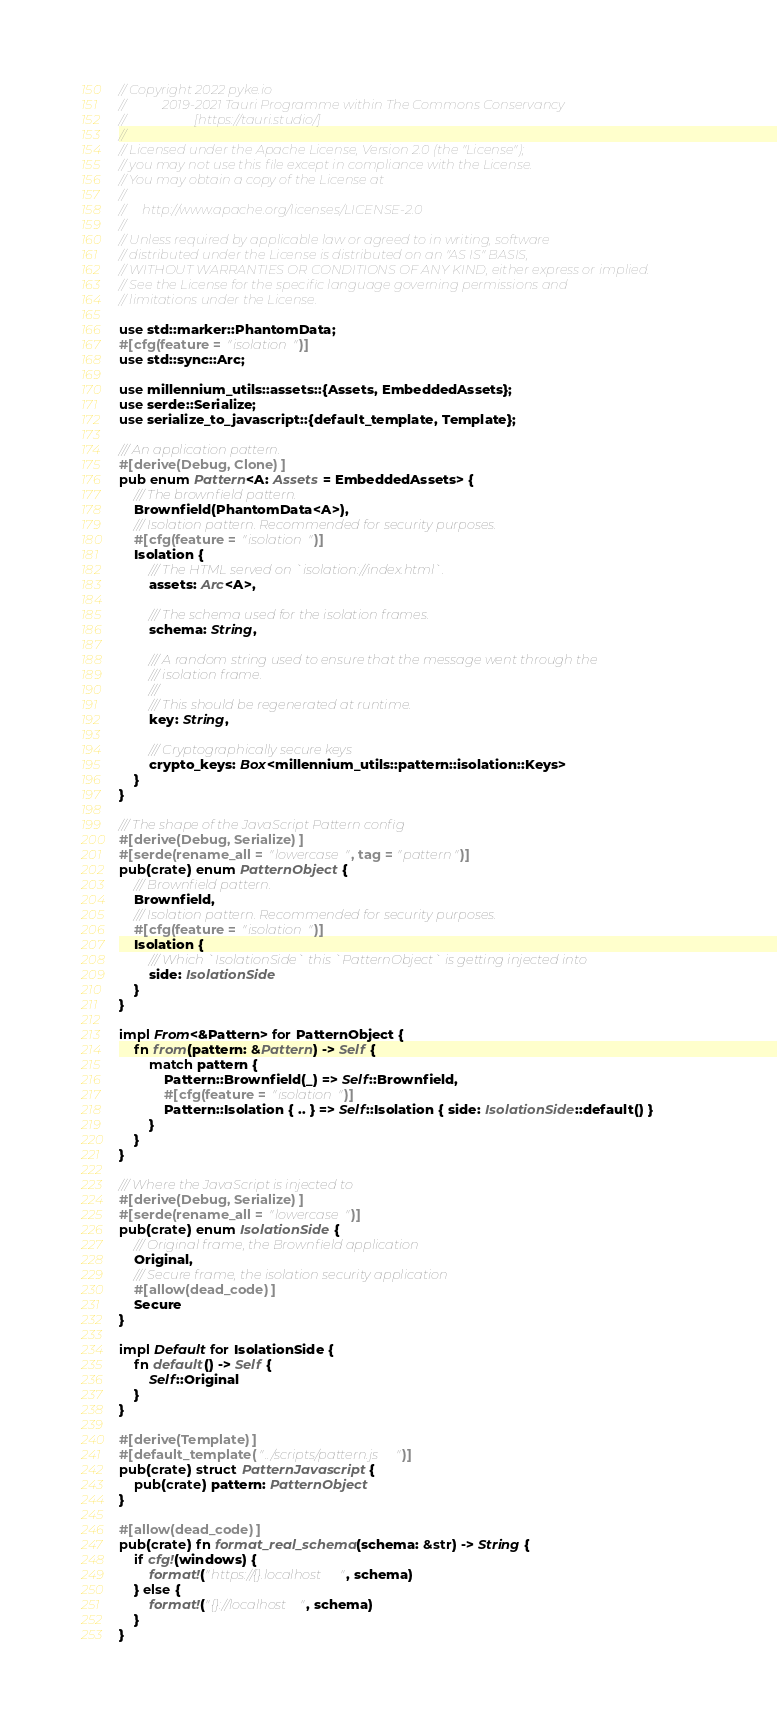Convert code to text. <code><loc_0><loc_0><loc_500><loc_500><_Rust_>// Copyright 2022 pyke.io
//           2019-2021 Tauri Programme within The Commons Conservancy
//                     [https://tauri.studio/]
//
// Licensed under the Apache License, Version 2.0 (the "License");
// you may not use this file except in compliance with the License.
// You may obtain a copy of the License at
//
//     http://www.apache.org/licenses/LICENSE-2.0
//
// Unless required by applicable law or agreed to in writing, software
// distributed under the License is distributed on an "AS IS" BASIS,
// WITHOUT WARRANTIES OR CONDITIONS OF ANY KIND, either express or implied.
// See the License for the specific language governing permissions and
// limitations under the License.

use std::marker::PhantomData;
#[cfg(feature = "isolation")]
use std::sync::Arc;

use millennium_utils::assets::{Assets, EmbeddedAssets};
use serde::Serialize;
use serialize_to_javascript::{default_template, Template};

/// An application pattern.
#[derive(Debug, Clone)]
pub enum Pattern<A: Assets = EmbeddedAssets> {
	/// The brownfield pattern.
	Brownfield(PhantomData<A>),
	/// Isolation pattern. Recommended for security purposes.
	#[cfg(feature = "isolation")]
	Isolation {
		/// The HTML served on `isolation://index.html`.
		assets: Arc<A>,

		/// The schema used for the isolation frames.
		schema: String,

		/// A random string used to ensure that the message went through the
		/// isolation frame.
		///
		/// This should be regenerated at runtime.
		key: String,

		/// Cryptographically secure keys
		crypto_keys: Box<millennium_utils::pattern::isolation::Keys>
	}
}

/// The shape of the JavaScript Pattern config
#[derive(Debug, Serialize)]
#[serde(rename_all = "lowercase", tag = "pattern")]
pub(crate) enum PatternObject {
	/// Brownfield pattern.
	Brownfield,
	/// Isolation pattern. Recommended for security purposes.
	#[cfg(feature = "isolation")]
	Isolation {
		/// Which `IsolationSide` this `PatternObject` is getting injected into
		side: IsolationSide
	}
}

impl From<&Pattern> for PatternObject {
	fn from(pattern: &Pattern) -> Self {
		match pattern {
			Pattern::Brownfield(_) => Self::Brownfield,
			#[cfg(feature = "isolation")]
			Pattern::Isolation { .. } => Self::Isolation { side: IsolationSide::default() }
		}
	}
}

/// Where the JavaScript is injected to
#[derive(Debug, Serialize)]
#[serde(rename_all = "lowercase")]
pub(crate) enum IsolationSide {
	/// Original frame, the Brownfield application
	Original,
	/// Secure frame, the isolation security application
	#[allow(dead_code)]
	Secure
}

impl Default for IsolationSide {
	fn default() -> Self {
		Self::Original
	}
}

#[derive(Template)]
#[default_template("../scripts/pattern.js")]
pub(crate) struct PatternJavascript {
	pub(crate) pattern: PatternObject
}

#[allow(dead_code)]
pub(crate) fn format_real_schema(schema: &str) -> String {
	if cfg!(windows) {
		format!("https://{}.localhost", schema)
	} else {
		format!("{}://localhost", schema)
	}
}
</code> 